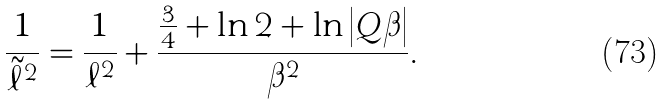<formula> <loc_0><loc_0><loc_500><loc_500>\frac { 1 } { \tilde { \ell } ^ { 2 } } = \frac { 1 } { \ell ^ { 2 } } + \frac { \frac { 3 } { 4 } + \ln 2 + \ln \left | Q \beta \right | } { \beta ^ { 2 } } .</formula> 